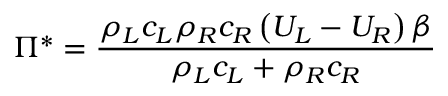<formula> <loc_0><loc_0><loc_500><loc_500>\Pi ^ { * } = \frac { \rho _ { L } c _ { L } \rho _ { R } c _ { R } \left ( U _ { L } - U _ { R } \right ) \beta } { \rho _ { L } c _ { L } + \rho _ { R } c _ { R } }</formula> 